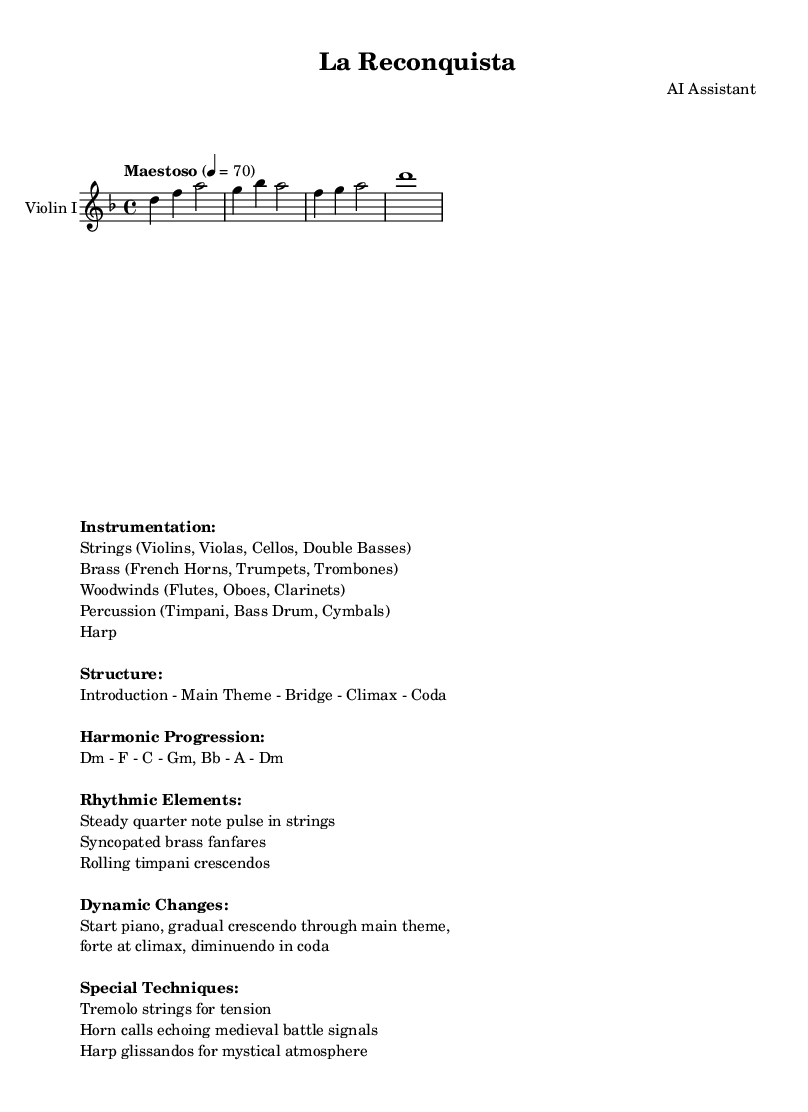What is the key signature of this music? The key signature is indicated at the beginning of the score with the sharp or flat symbols, which indicate the notes that are altered. Here, it shows one flat indicating D minor.
Answer: D minor What is the time signature of the piece? The time signature is found next to the clef at the beginning of the score, showing how many beats are in each measure. In this case, it reads 4/4, meaning there are four beats per measure.
Answer: 4/4 What is the tempo marking for this score? The tempo marking is also provided at the beginning of the score, indicating the speed of the piece. It states "Maestoso" with a metronome marking of 70 beats per minute, suggesting a slow and majestic pace.
Answer: Maestoso, 70 What instruments are included in the orchestration? The instrumentation is listed in the markup section, specifying which types of instruments play in the piece. It includes strings, brass, woodwinds, percussion, and harp.
Answer: Strings, Brass, Woodwinds, Percussion, Harp What is the dynamic change throughout the piece? The dynamic changes are described in the markup, detailing how loud or soft the music should be at different sections. Initially, it starts piano (soft), then crescendos to fortissimo (very loud) at the climax, followed by a diminuendo (softening) in the coda.
Answer: Piano, crescendo, fortissimo, diminuendo What special techniques are used in this score? The special techniques are listed in the markup section under the "Special Techniques" heading. It includes tremolo strings, horn calls, and harp glissandos which contribute to the music's dramatic effect.
Answer: Tremolo, horn calls, harp glissandos 